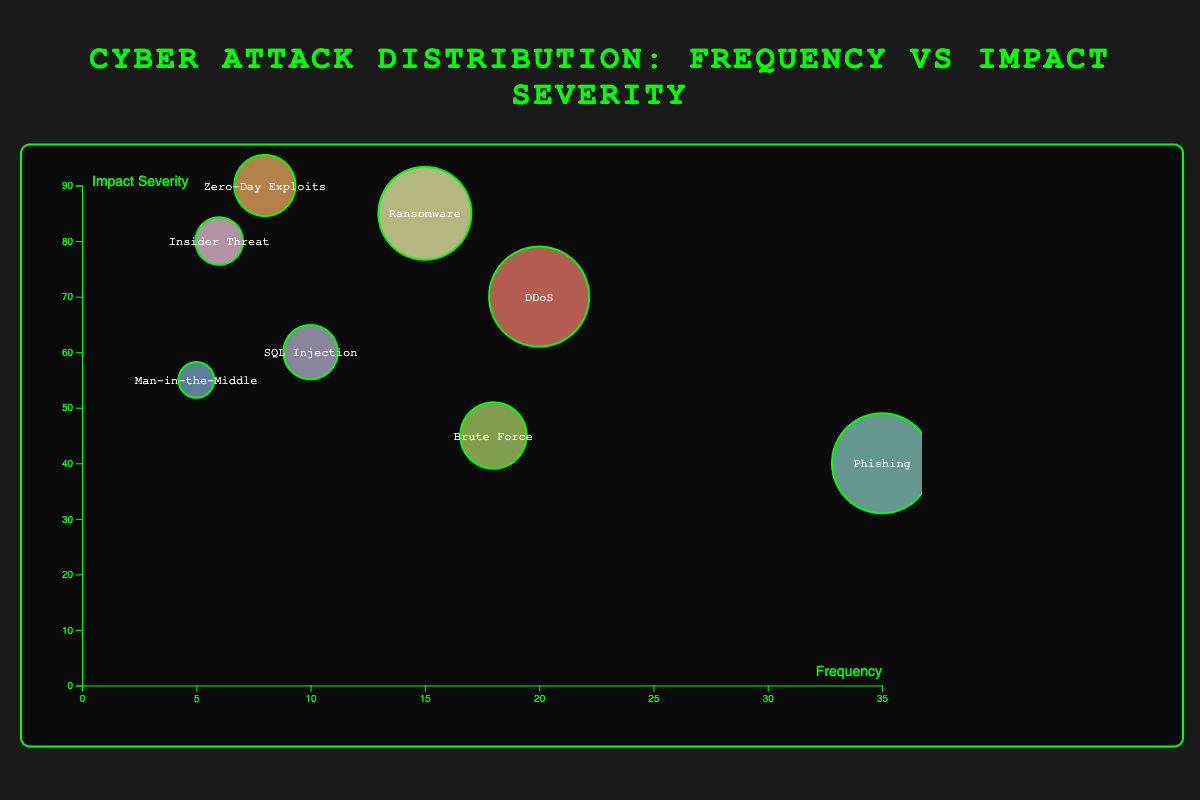What is the most frequent type of cyber attack? By examining the data points represented as bubbles, the type with the highest position on the x-axis indicates the highest frequency. The "Phishing" attack is at the highest x-axis value (35).
Answer: Phishing Which cyber attack type has the highest impact severity? Looking at the data points, the type at the highest position on the y-axis indicates the highest impact severity. The "Zero-Day Exploits" attack is at the highest y-axis value (90).
Answer: Zero-Day Exploits What is the color of the bubble representing Ransomware attacks? By identifying the "Ransomware" label in the bubble and observing its surrounding appearance, one can determine its color based on the color palette used. The "Ransomware" attack's bubble appears to be represented with a red color.
Answer: Red How many cyber attack types have a frequency of less than 10? Counting the bubbles that fall to the left of the x-axis value of 10 helps identify the attack types. There are three such bubbles: "SQL Injection," "Man-in-the-Middle," and "Insider Threat."
Answer: 3 Which cyber attack type has the largest bubble size? Bubble size is proportional to the product of frequency and impact severity. The "Phishing" attack, due to its high frequency, has the largest bubble size.
Answer: Phishing Which cyber attack type is more frequent: "DDoS" or "Brute Force"? Comparing the x-axis positions of the "DDoS" and "Brute Force" bubbles, "DDoS" has a frequency of 20 while "Brute Force" has a frequency of 18.
Answer: DDoS What is the difference in impact severity between the "SQL Injection" and "Brute Force" attacks? The impact severity on the y-axis for "SQL Injection" is 60 and for "Brute Force" is 45. The difference can be calculated as 60 - 45.
Answer: 15 Which cyber attack type has both a high frequency and high impact severity? By analyzing bubbles located in the upper right quadrant of the plot (high x and y values), "Phishing" (frequency 35, impact severity 40) and "Ransomware" (frequency 15, impact severity 85) fit this description. However, "Phishing" stands out even more in terms of frequency.
Answer: Phishing and Ransomware What is the total number of cyber attack types represented in the chart? Counting all unique data points (bubbles) in the chart gives the total number of types. There are 8 different cyber attack types shown.
Answer: 8 